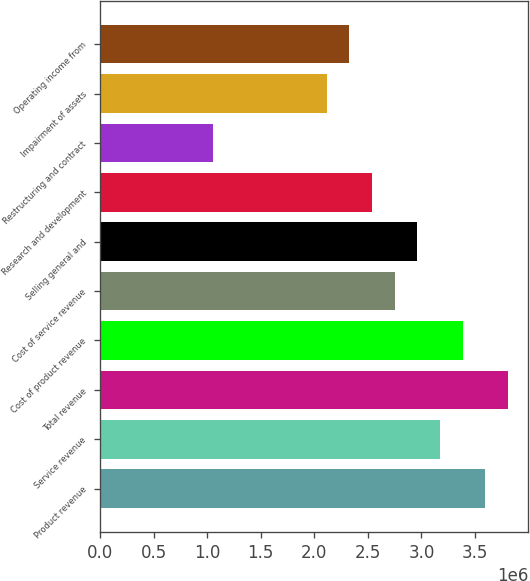<chart> <loc_0><loc_0><loc_500><loc_500><bar_chart><fcel>Product revenue<fcel>Service revenue<fcel>Total revenue<fcel>Cost of product revenue<fcel>Cost of service revenue<fcel>Selling general and<fcel>Research and development<fcel>Restructuring and contract<fcel>Impairment of assets<fcel>Operating income from<nl><fcel>3.59585e+06<fcel>3.17281e+06<fcel>3.80737e+06<fcel>3.38433e+06<fcel>2.74977e+06<fcel>2.96129e+06<fcel>2.53825e+06<fcel>1.0576e+06<fcel>2.11521e+06<fcel>2.32673e+06<nl></chart> 